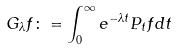Convert formula to latex. <formula><loc_0><loc_0><loc_500><loc_500>G _ { \lambda } f \colon = \int _ { 0 } ^ { \infty } e ^ { - \lambda t } P _ { t } f d t</formula> 